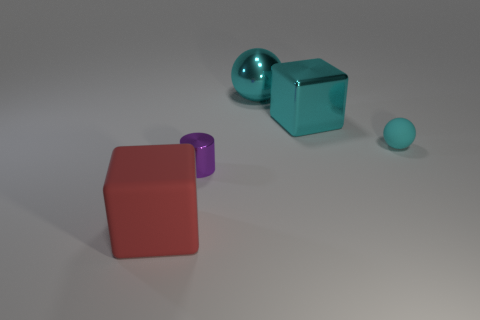Add 3 small cyan rubber objects. How many objects exist? 8 Subtract all red cubes. How many cubes are left? 1 Subtract 1 blocks. How many blocks are left? 1 Subtract all balls. How many objects are left? 3 Subtract all green cubes. Subtract all blue cylinders. How many cubes are left? 2 Subtract all large purple things. Subtract all red objects. How many objects are left? 4 Add 2 cubes. How many cubes are left? 4 Add 2 small purple rubber cylinders. How many small purple rubber cylinders exist? 2 Subtract 0 purple spheres. How many objects are left? 5 